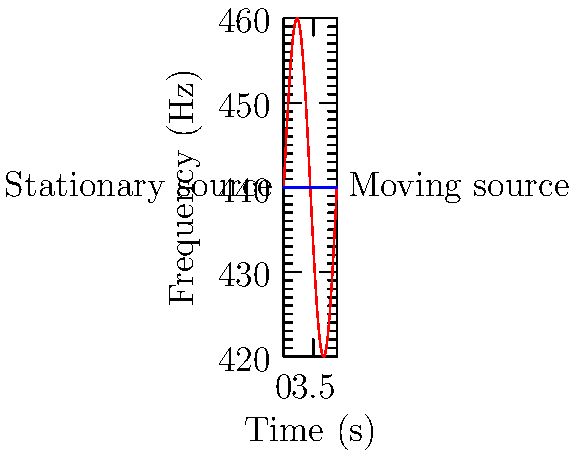In the graph above, the red curve represents the frequency change over time for a moving sound source (e.g., a police siren passing by), while the blue line represents a stationary source. Based on this representation of the Doppler effect, what is the approximate maximum frequency shift (in Hz) experienced by a stationary observer as the moving source passes by? To determine the maximum frequency shift due to the Doppler effect:

1. Identify the baseline frequency:
   The blue line represents a stationary source at 440 Hz.

2. Find the peak of the red curve:
   The red curve oscillates above and below the baseline.

3. Estimate the maximum amplitude:
   The curve reaches about 20 Hz above the baseline.

4. Calculate the frequency shift:
   Maximum shift = Peak frequency - Baseline frequency
   $\approx (440 + 20) - 440 = 20$ Hz

5. Verify the result:
   The curve also dips about 20 Hz below the baseline, confirming the symmetry of the Doppler effect as the source approaches and recedes.

Therefore, the maximum frequency shift experienced by the stationary observer is approximately 20 Hz.
Answer: 20 Hz 